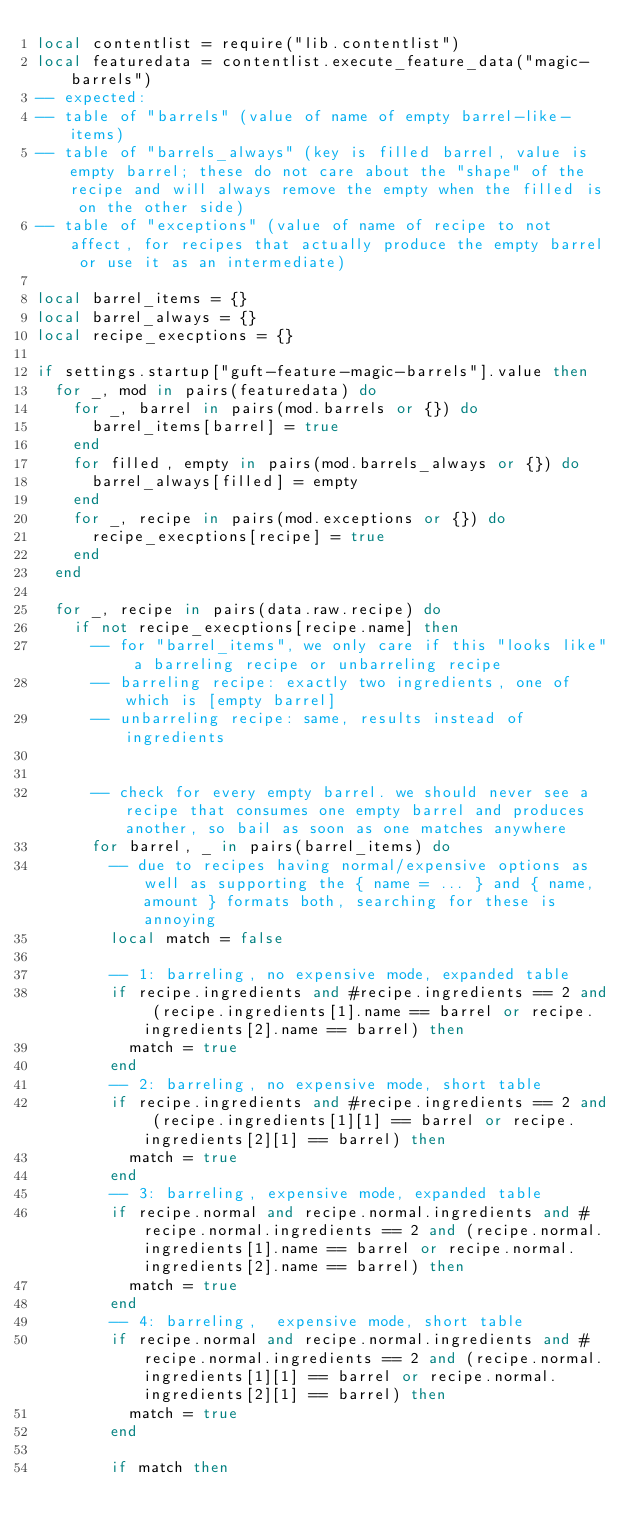Convert code to text. <code><loc_0><loc_0><loc_500><loc_500><_Lua_>local contentlist = require("lib.contentlist")
local featuredata = contentlist.execute_feature_data("magic-barrels")
-- expected:
-- table of "barrels" (value of name of empty barrel-like-items)
-- table of "barrels_always" (key is filled barrel, value is empty barrel; these do not care about the "shape" of the recipe and will always remove the empty when the filled is on the other side)
-- table of "exceptions" (value of name of recipe to not affect, for recipes that actually produce the empty barrel or use it as an intermediate)

local barrel_items = {}
local barrel_always = {}
local recipe_execptions = {}

if settings.startup["guft-feature-magic-barrels"].value then
	for _, mod in pairs(featuredata) do
		for _, barrel in pairs(mod.barrels or {}) do
			barrel_items[barrel] = true
		end
		for filled, empty in pairs(mod.barrels_always or {}) do
			barrel_always[filled] = empty
		end
		for _, recipe in pairs(mod.exceptions or {}) do
			recipe_execptions[recipe] = true
		end
	end

	for _, recipe in pairs(data.raw.recipe) do
		if not recipe_execptions[recipe.name] then
			-- for "barrel_items", we only care if this "looks like" a barreling recipe or unbarreling recipe
			-- barreling recipe: exactly two ingredients, one of which is [empty barrel]
			-- unbarreling recipe: same, results instead of ingredients

			
			-- check for every empty barrel. we should never see a recipe that consumes one empty barrel and produces another, so bail as soon as one matches anywhere
			for barrel, _ in pairs(barrel_items) do
				-- due to recipes having normal/expensive options as well as supporting the { name = ... } and { name, amount } formats both, searching for these is annoying
				local match = false

				-- 1: barreling, no expensive mode, expanded table
				if recipe.ingredients and #recipe.ingredients == 2 and (recipe.ingredients[1].name == barrel or recipe.ingredients[2].name == barrel) then
					match = true
				end
				-- 2: barreling, no expensive mode, short table
				if recipe.ingredients and #recipe.ingredients == 2 and (recipe.ingredients[1][1] == barrel or recipe.ingredients[2][1] == barrel) then
					match = true
				end
				-- 3: barreling, expensive mode, expanded table
				if recipe.normal and recipe.normal.ingredients and #recipe.normal.ingredients == 2 and (recipe.normal.ingredients[1].name == barrel or recipe.normal.ingredients[2].name == barrel) then
					match = true
				end
				-- 4: barreling,  expensive mode, short table
				if recipe.normal and recipe.normal.ingredients and #recipe.normal.ingredients == 2 and (recipe.normal.ingredients[1][1] == barrel or recipe.normal.ingredients[2][1] == barrel) then
					match = true
				end

				if match then</code> 